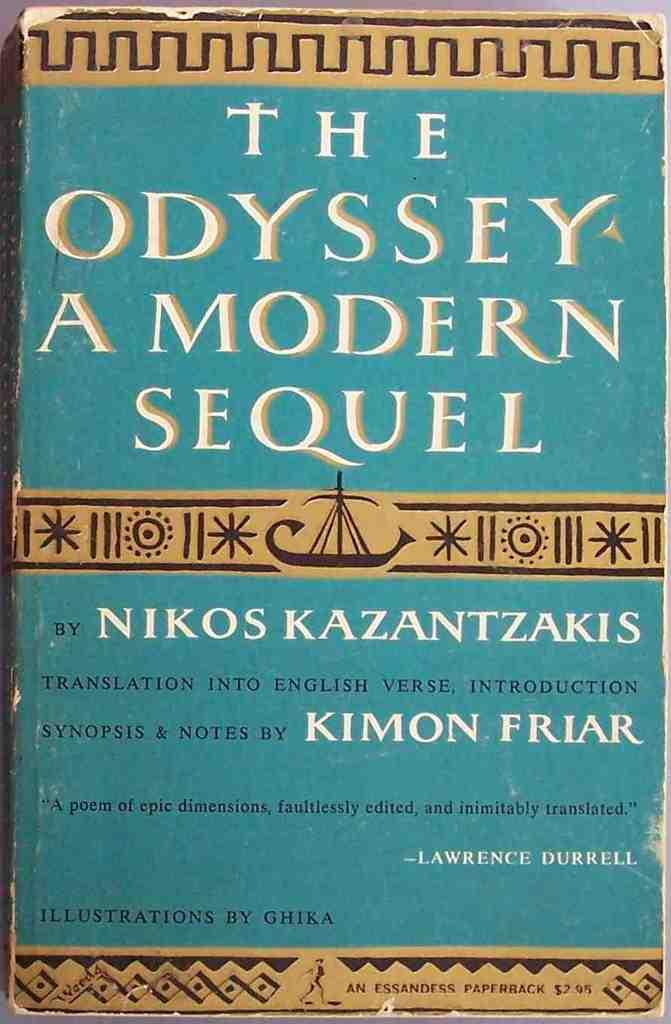<image>
Offer a succinct explanation of the picture presented. The Odyssey A modern sequel by Nikos Kazantzakis and translation by Kimon Friar. 